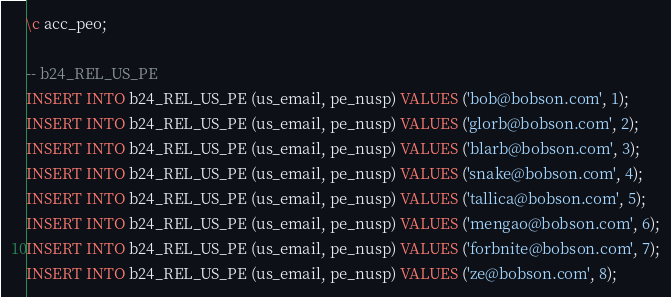Convert code to text. <code><loc_0><loc_0><loc_500><loc_500><_SQL_>\c acc_peo;

-- b24_REL_US_PE
INSERT INTO b24_REL_US_PE (us_email, pe_nusp) VALUES ('bob@bobson.com', 1);
INSERT INTO b24_REL_US_PE (us_email, pe_nusp) VALUES ('glorb@bobson.com', 2);
INSERT INTO b24_REL_US_PE (us_email, pe_nusp) VALUES ('blarb@bobson.com', 3);
INSERT INTO b24_REL_US_PE (us_email, pe_nusp) VALUES ('snake@bobson.com', 4);
INSERT INTO b24_REL_US_PE (us_email, pe_nusp) VALUES ('tallica@bobson.com', 5);
INSERT INTO b24_REL_US_PE (us_email, pe_nusp) VALUES ('mengao@bobson.com', 6);
INSERT INTO b24_REL_US_PE (us_email, pe_nusp) VALUES ('forbnite@bobson.com', 7);
INSERT INTO b24_REL_US_PE (us_email, pe_nusp) VALUES ('ze@bobson.com', 8);</code> 